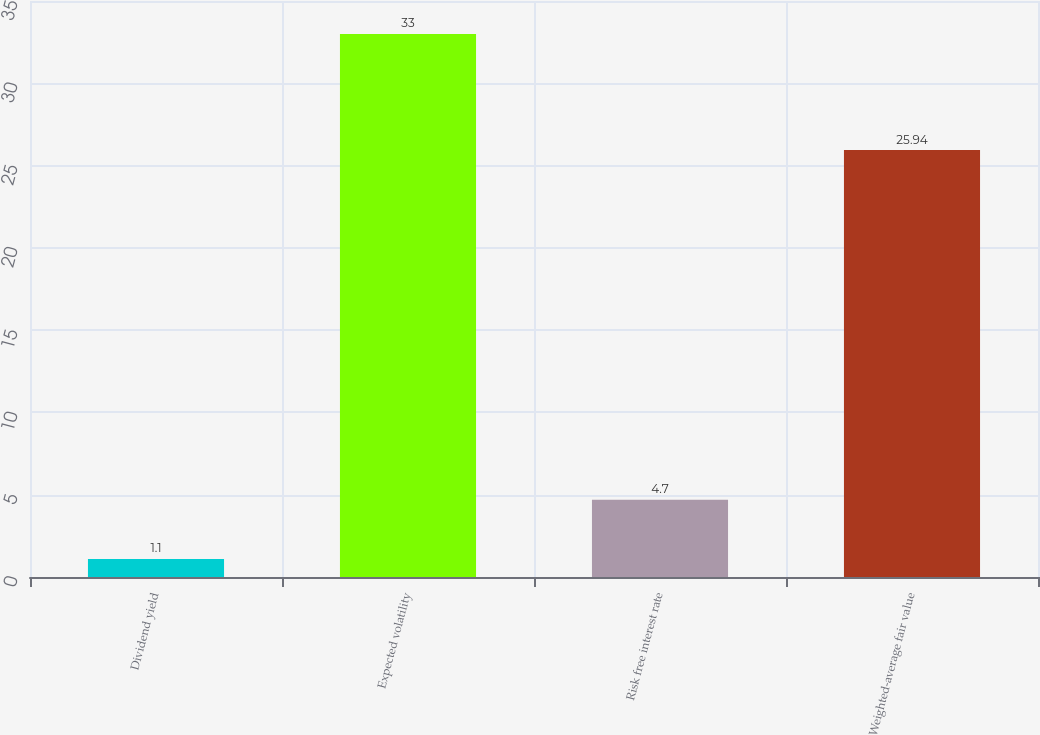<chart> <loc_0><loc_0><loc_500><loc_500><bar_chart><fcel>Dividend yield<fcel>Expected volatility<fcel>Risk free interest rate<fcel>Weighted-average fair value<nl><fcel>1.1<fcel>33<fcel>4.7<fcel>25.94<nl></chart> 